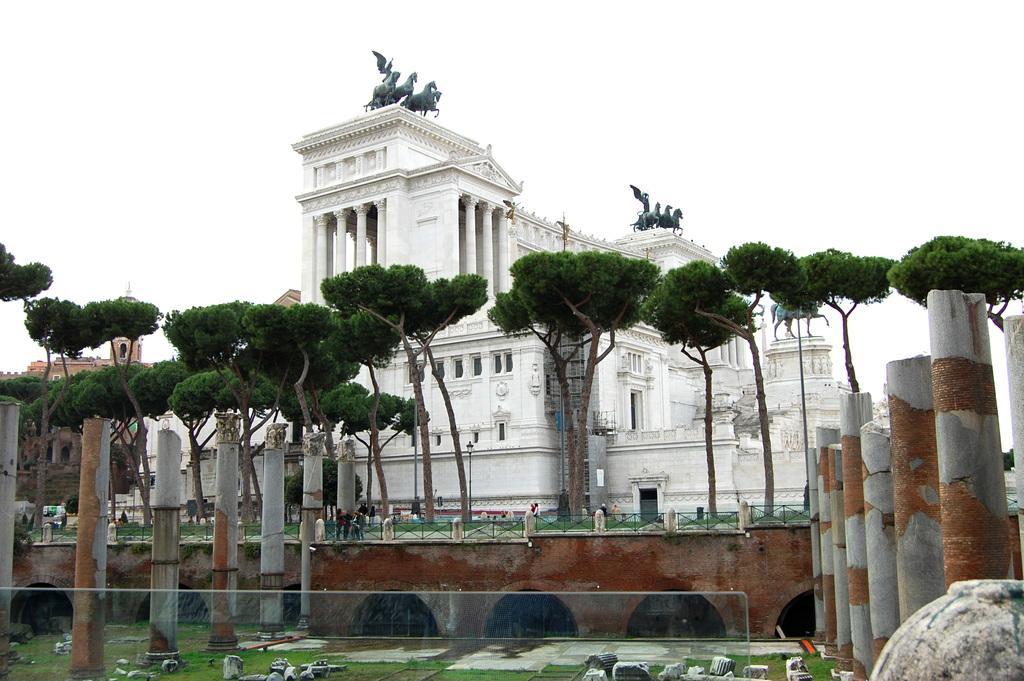In one or two sentences, can you explain what this image depicts? In this picture there are buildings and there are statues on the building. In the foreground there are trees and there are group of people and there are pillars. At the top there is sky. At the bottom there is grass and there are objects. 